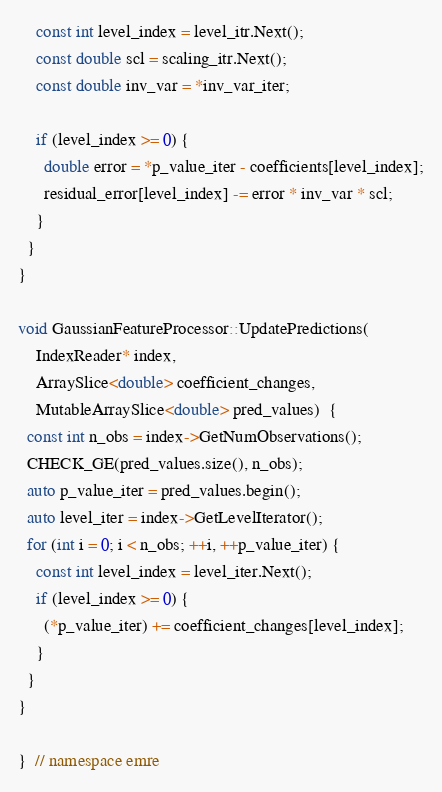<code> <loc_0><loc_0><loc_500><loc_500><_C++_>    const int level_index = level_itr.Next();
    const double scl = scaling_itr.Next();
    const double inv_var = *inv_var_iter;

    if (level_index >= 0) {
      double error = *p_value_iter - coefficients[level_index];
      residual_error[level_index] -= error * inv_var * scl;
    }
  }
}

void GaussianFeatureProcessor::UpdatePredictions(
    IndexReader* index,
    ArraySlice<double> coefficient_changes,
    MutableArraySlice<double> pred_values)  {
  const int n_obs = index->GetNumObservations();
  CHECK_GE(pred_values.size(), n_obs);
  auto p_value_iter = pred_values.begin();
  auto level_iter = index->GetLevelIterator();
  for (int i = 0; i < n_obs; ++i, ++p_value_iter) {
    const int level_index = level_iter.Next();
    if (level_index >= 0) {
      (*p_value_iter) += coefficient_changes[level_index];
    }
  }
}

}  // namespace emre
</code> 